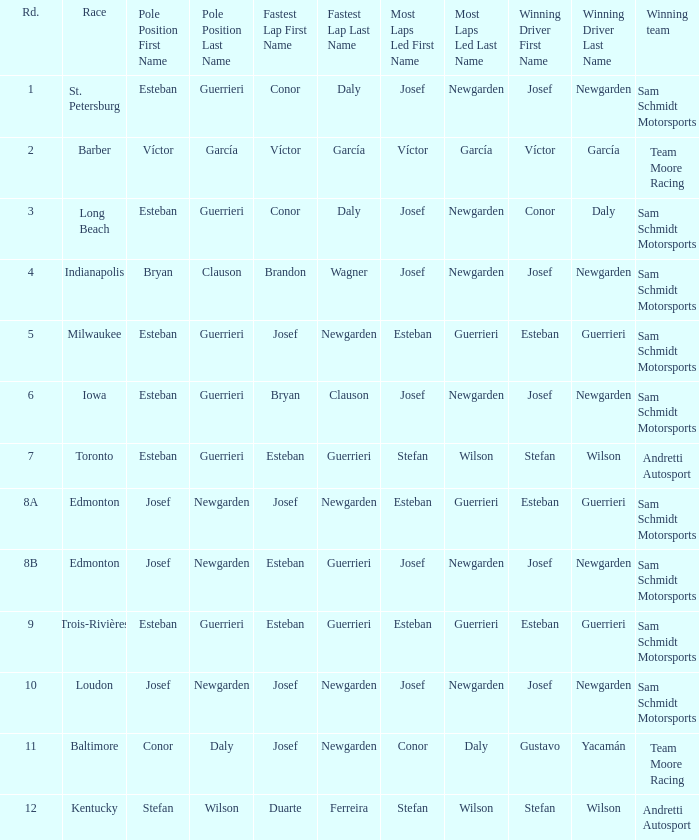Who had the fastest lap(s) when josef newgarden led the most laps at edmonton? Esteban Guerrieri. 